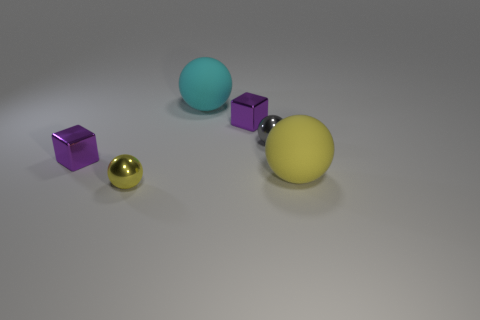Subtract all purple balls. Subtract all cyan cylinders. How many balls are left? 4 Add 1 tiny metallic cubes. How many objects exist? 7 Subtract all spheres. How many objects are left? 2 Add 5 small gray objects. How many small gray objects are left? 6 Add 1 small gray balls. How many small gray balls exist? 2 Subtract 1 gray spheres. How many objects are left? 5 Subtract all big gray metallic balls. Subtract all cyan balls. How many objects are left? 5 